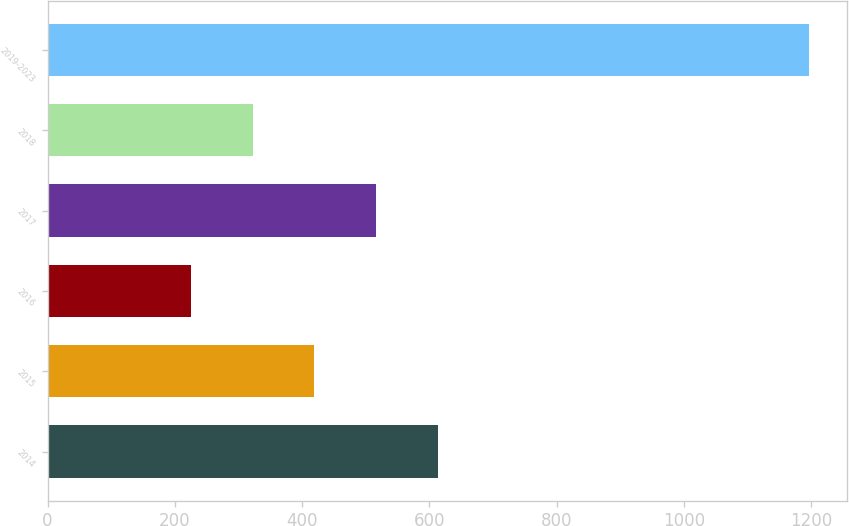Convert chart to OTSL. <chart><loc_0><loc_0><loc_500><loc_500><bar_chart><fcel>2014<fcel>2015<fcel>2016<fcel>2017<fcel>2018<fcel>2019-2023<nl><fcel>613.4<fcel>419.2<fcel>225<fcel>516.3<fcel>322.1<fcel>1196<nl></chart> 